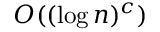<formula> <loc_0><loc_0><loc_500><loc_500>O ( ( \log n ) ^ { c } )</formula> 